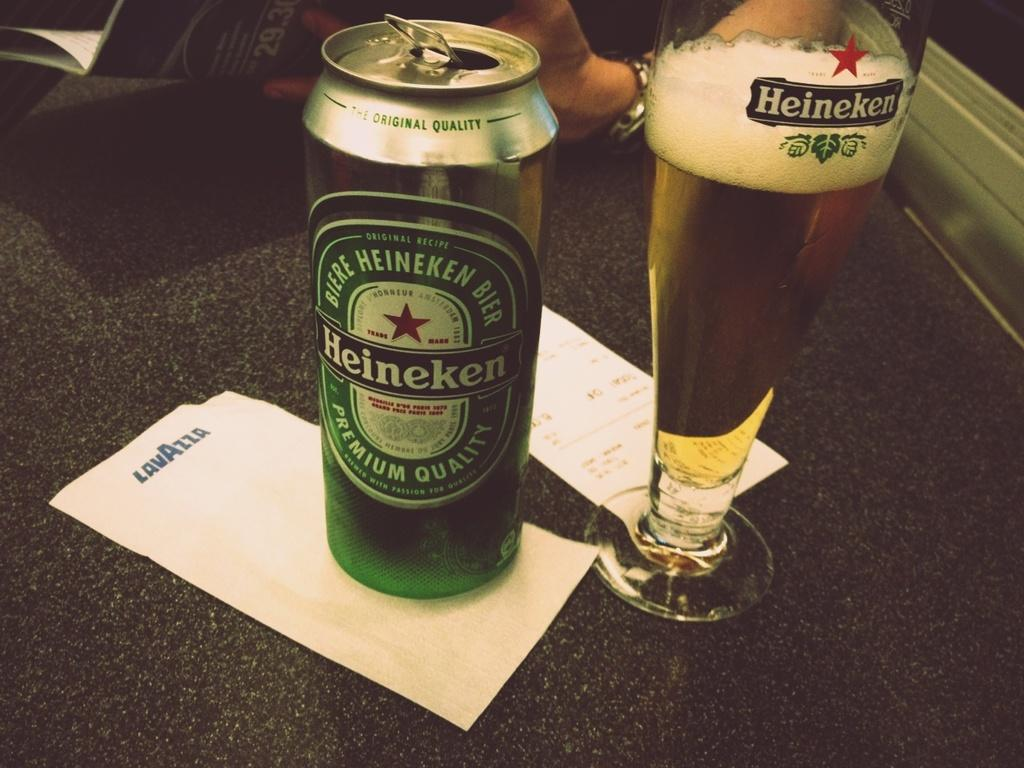<image>
Provide a brief description of the given image. A can of Heineken beer sits next to a full pint glass. 